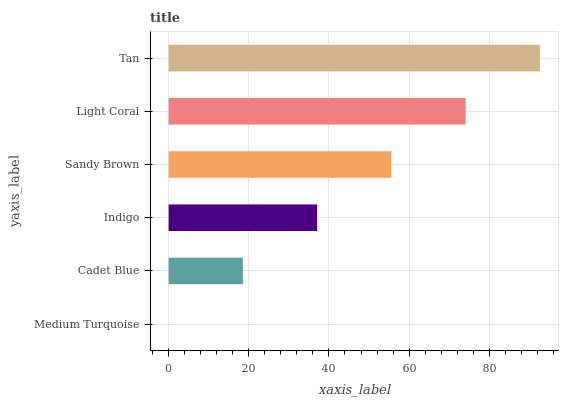Is Medium Turquoise the minimum?
Answer yes or no. Yes. Is Tan the maximum?
Answer yes or no. Yes. Is Cadet Blue the minimum?
Answer yes or no. No. Is Cadet Blue the maximum?
Answer yes or no. No. Is Cadet Blue greater than Medium Turquoise?
Answer yes or no. Yes. Is Medium Turquoise less than Cadet Blue?
Answer yes or no. Yes. Is Medium Turquoise greater than Cadet Blue?
Answer yes or no. No. Is Cadet Blue less than Medium Turquoise?
Answer yes or no. No. Is Sandy Brown the high median?
Answer yes or no. Yes. Is Indigo the low median?
Answer yes or no. Yes. Is Cadet Blue the high median?
Answer yes or no. No. Is Light Coral the low median?
Answer yes or no. No. 